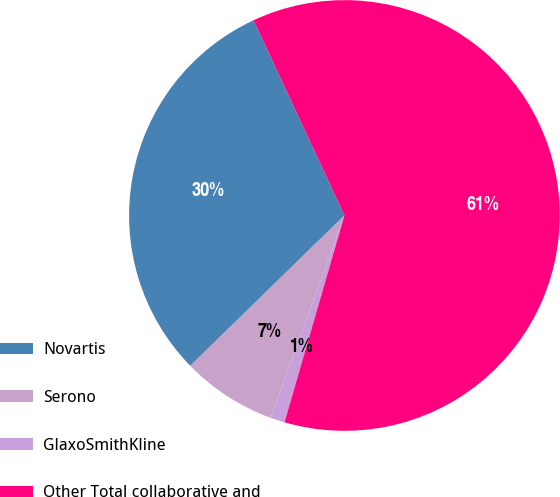Convert chart. <chart><loc_0><loc_0><loc_500><loc_500><pie_chart><fcel>Novartis<fcel>Serono<fcel>GlaxoSmithKline<fcel>Other Total collaborative and<nl><fcel>30.37%<fcel>7.12%<fcel>1.09%<fcel>61.42%<nl></chart> 